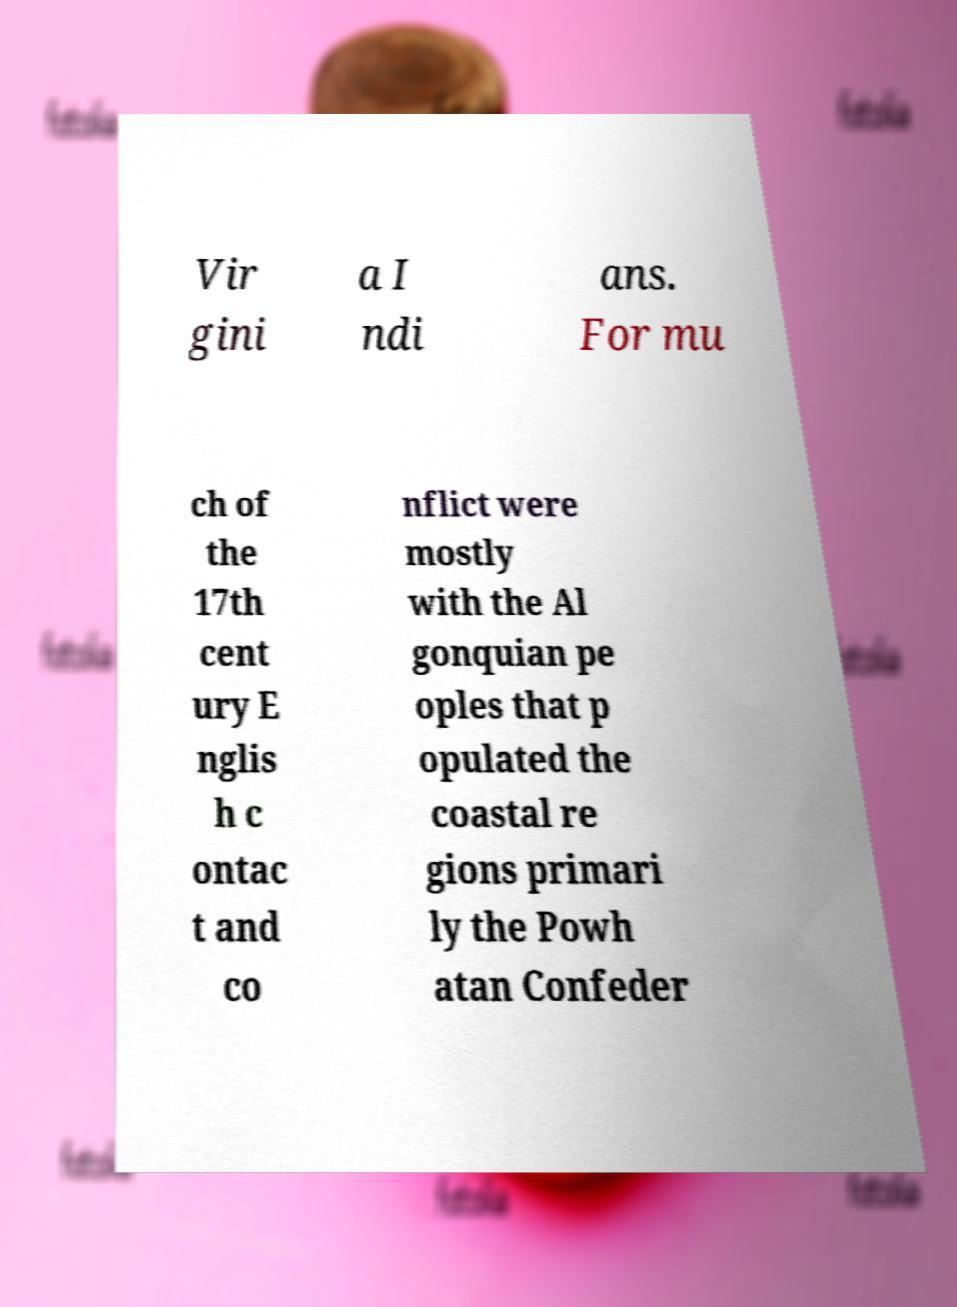What messages or text are displayed in this image? I need them in a readable, typed format. Vir gini a I ndi ans. For mu ch of the 17th cent ury E nglis h c ontac t and co nflict were mostly with the Al gonquian pe oples that p opulated the coastal re gions primari ly the Powh atan Confeder 